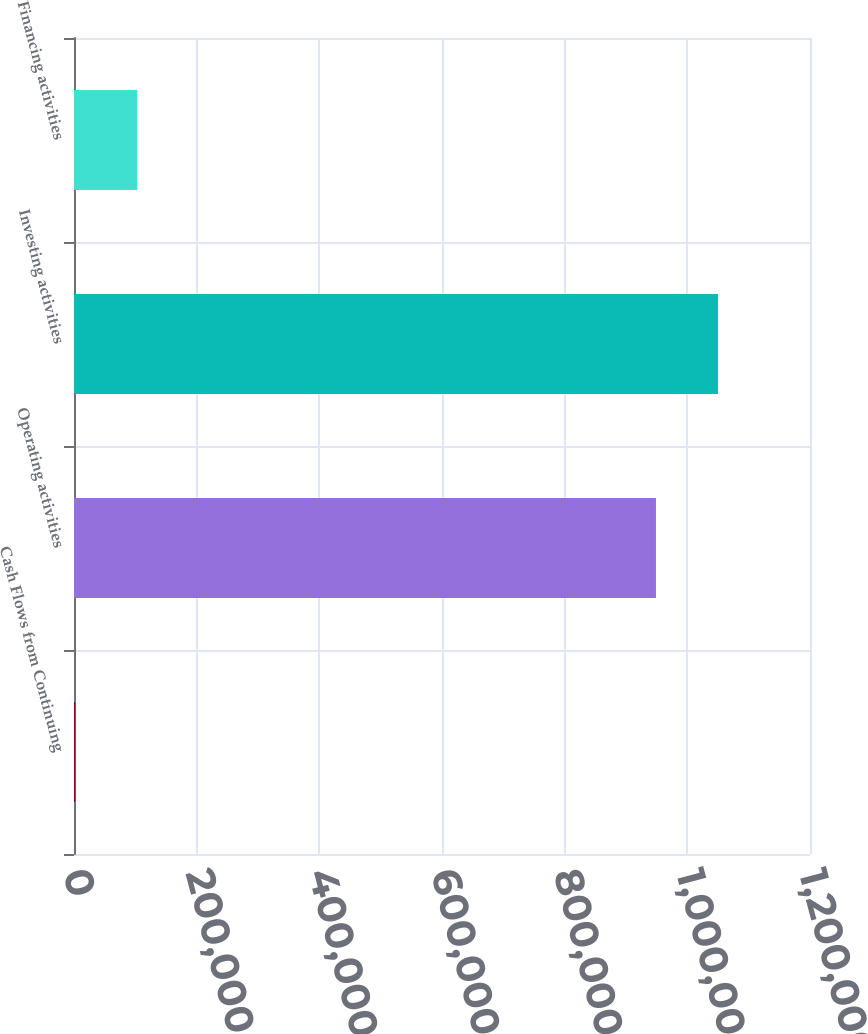Convert chart. <chart><loc_0><loc_0><loc_500><loc_500><bar_chart><fcel>Cash Flows from Continuing<fcel>Operating activities<fcel>Investing activities<fcel>Financing activities<nl><fcel>2011<fcel>948864<fcel>1.04991e+06<fcel>103053<nl></chart> 